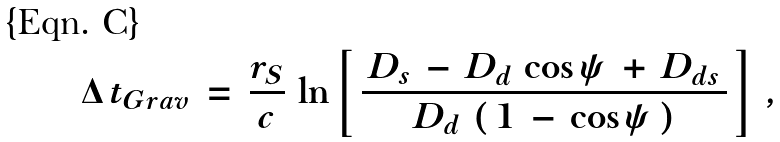<formula> <loc_0><loc_0><loc_500><loc_500>\Delta \, t _ { G r a v } \, = \, \frac { r _ { S } } { c } \, \ln \left [ \, \frac { \, D _ { s } \, - \, D _ { d } \, \cos \psi \, + \, D _ { d s } \, } { D _ { d } \, \left ( \, 1 \, - \, \cos \psi \, \right ) } \, \right ] \, ,</formula> 